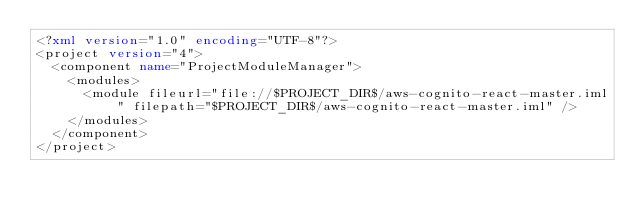<code> <loc_0><loc_0><loc_500><loc_500><_XML_><?xml version="1.0" encoding="UTF-8"?>
<project version="4">
  <component name="ProjectModuleManager">
    <modules>
      <module fileurl="file://$PROJECT_DIR$/aws-cognito-react-master.iml" filepath="$PROJECT_DIR$/aws-cognito-react-master.iml" />
    </modules>
  </component>
</project></code> 